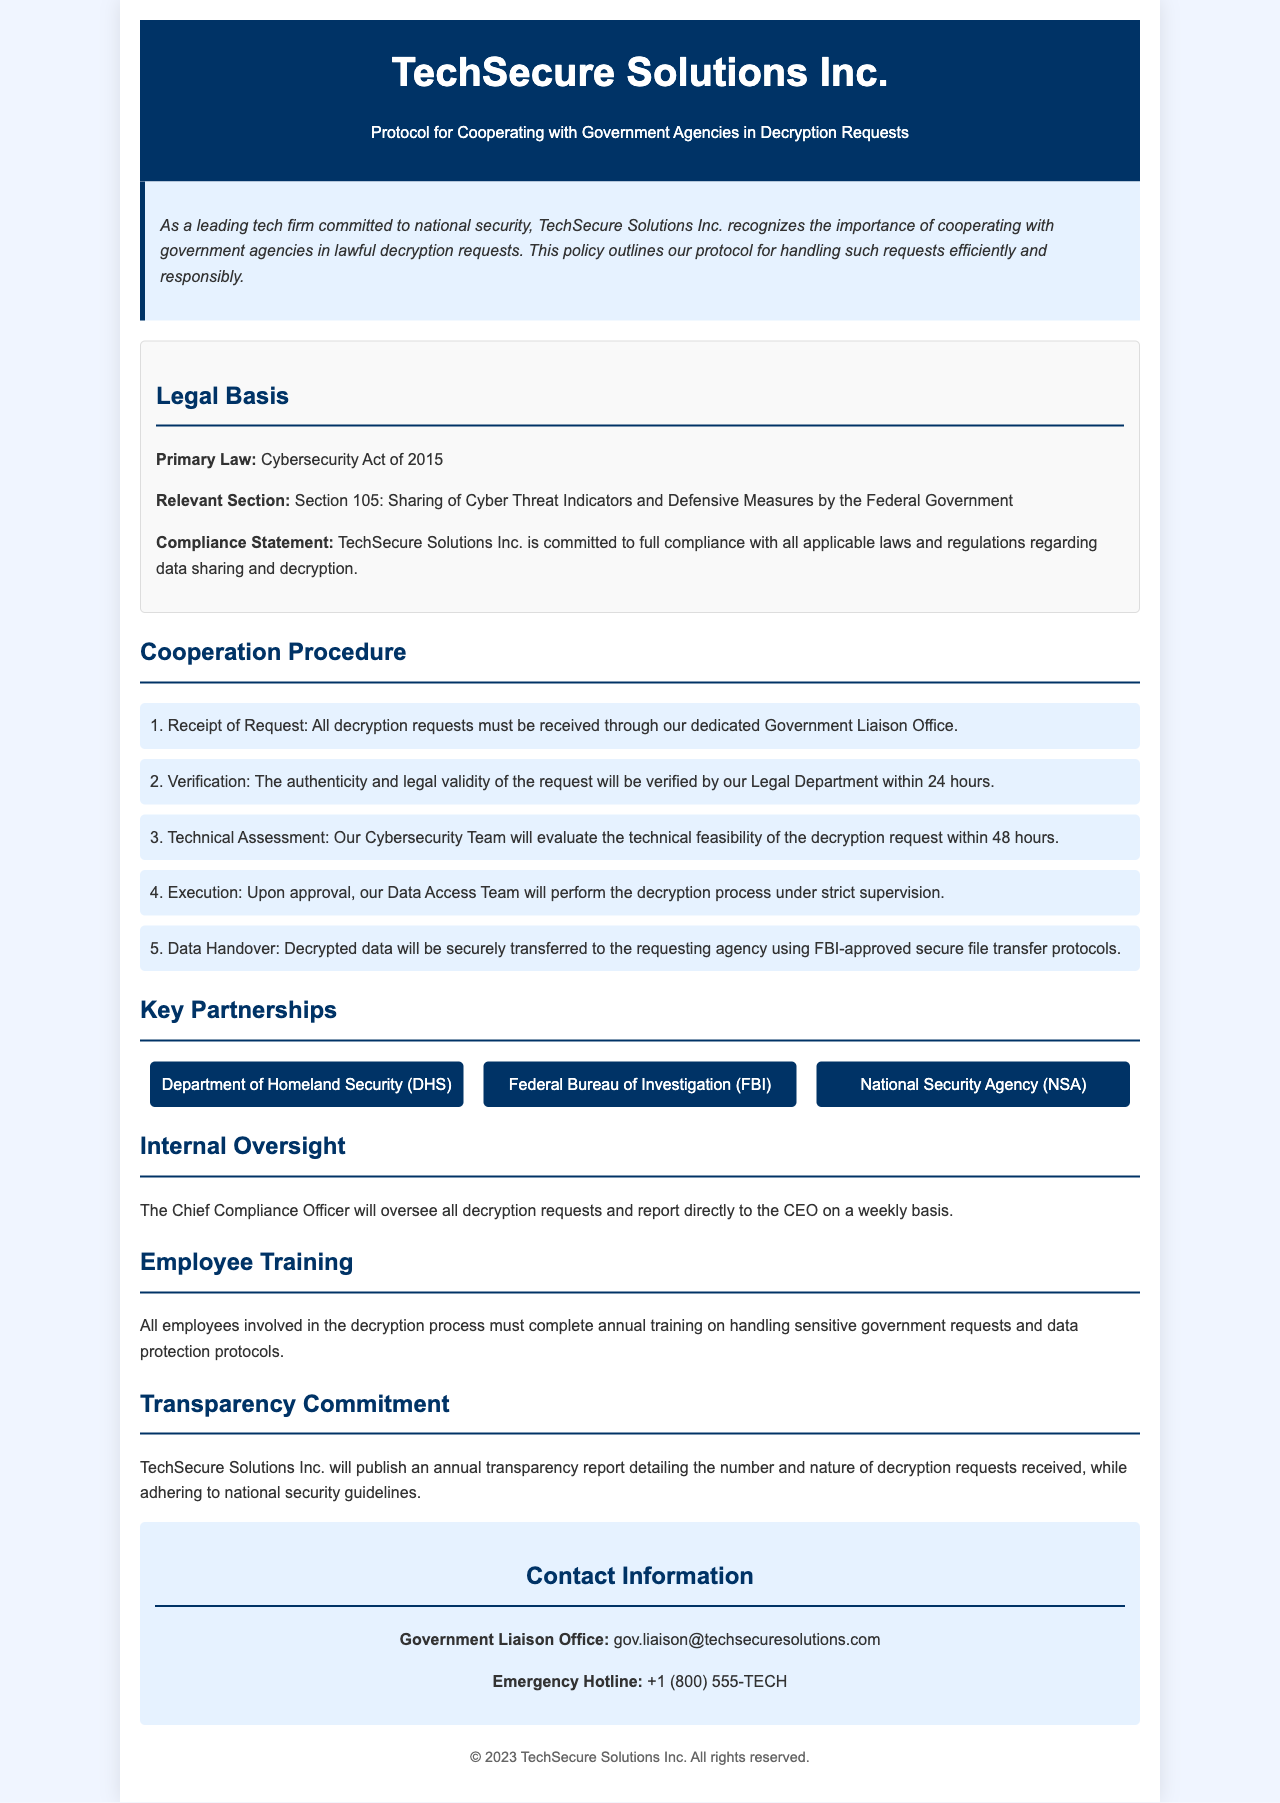What is the primary law governing this protocol? The primary law that this protocol is based on is mentioned in the legal basis section.
Answer: Cybersecurity Act of 2015 What is the role of the Chief Compliance Officer? The document states that the Chief Compliance Officer oversees decryption requests and reports to the CEO.
Answer: Oversee decryption requests How many hours for verification of requests? The timeframe for verification is specified in the procedure section of the document.
Answer: 24 hours Which agency is NOT listed as a key partnership? By reviewing the key partnerships section, one can identify the agencies included.
Answer: None What is the emergency hotline number provided? This information is found in the contact information section.
Answer: +1 (800) 555-TECH What happens during the technical assessment phase? The document describes what occurs in this step of the procedure for cooperation.
Answer: Evaluate technical feasibility How often is the Chief Compliance Officer expected to report to the CEO? Document states the frequency of reporting regarding decryption requests.
Answer: Weekly What is the form of data transfer used for decrypted data? The document mentions the method for transferring decrypted data securely.
Answer: FBI-approved secure file transfer protocols What type of training is required for employees involved in the decryption process? This aspect is highlighted in the employee training section of the document.
Answer: Annual training 